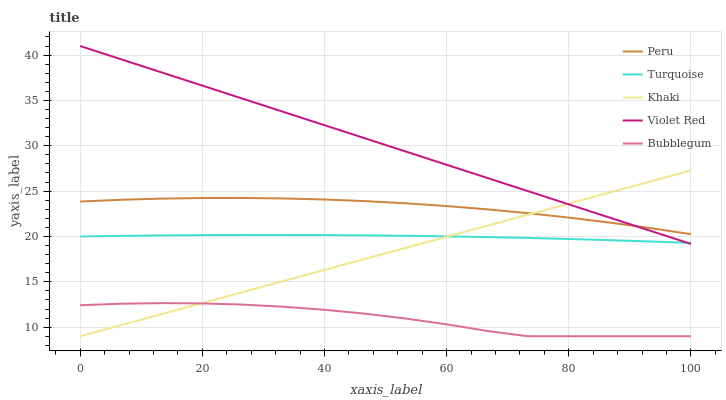Does Bubblegum have the minimum area under the curve?
Answer yes or no. Yes. Does Violet Red have the maximum area under the curve?
Answer yes or no. Yes. Does Khaki have the minimum area under the curve?
Answer yes or no. No. Does Khaki have the maximum area under the curve?
Answer yes or no. No. Is Khaki the smoothest?
Answer yes or no. Yes. Is Bubblegum the roughest?
Answer yes or no. Yes. Is Bubblegum the smoothest?
Answer yes or no. No. Is Khaki the roughest?
Answer yes or no. No. Does Khaki have the lowest value?
Answer yes or no. Yes. Does Violet Red have the lowest value?
Answer yes or no. No. Does Violet Red have the highest value?
Answer yes or no. Yes. Does Khaki have the highest value?
Answer yes or no. No. Is Bubblegum less than Turquoise?
Answer yes or no. Yes. Is Violet Red greater than Bubblegum?
Answer yes or no. Yes. Does Violet Red intersect Turquoise?
Answer yes or no. Yes. Is Violet Red less than Turquoise?
Answer yes or no. No. Is Violet Red greater than Turquoise?
Answer yes or no. No. Does Bubblegum intersect Turquoise?
Answer yes or no. No. 